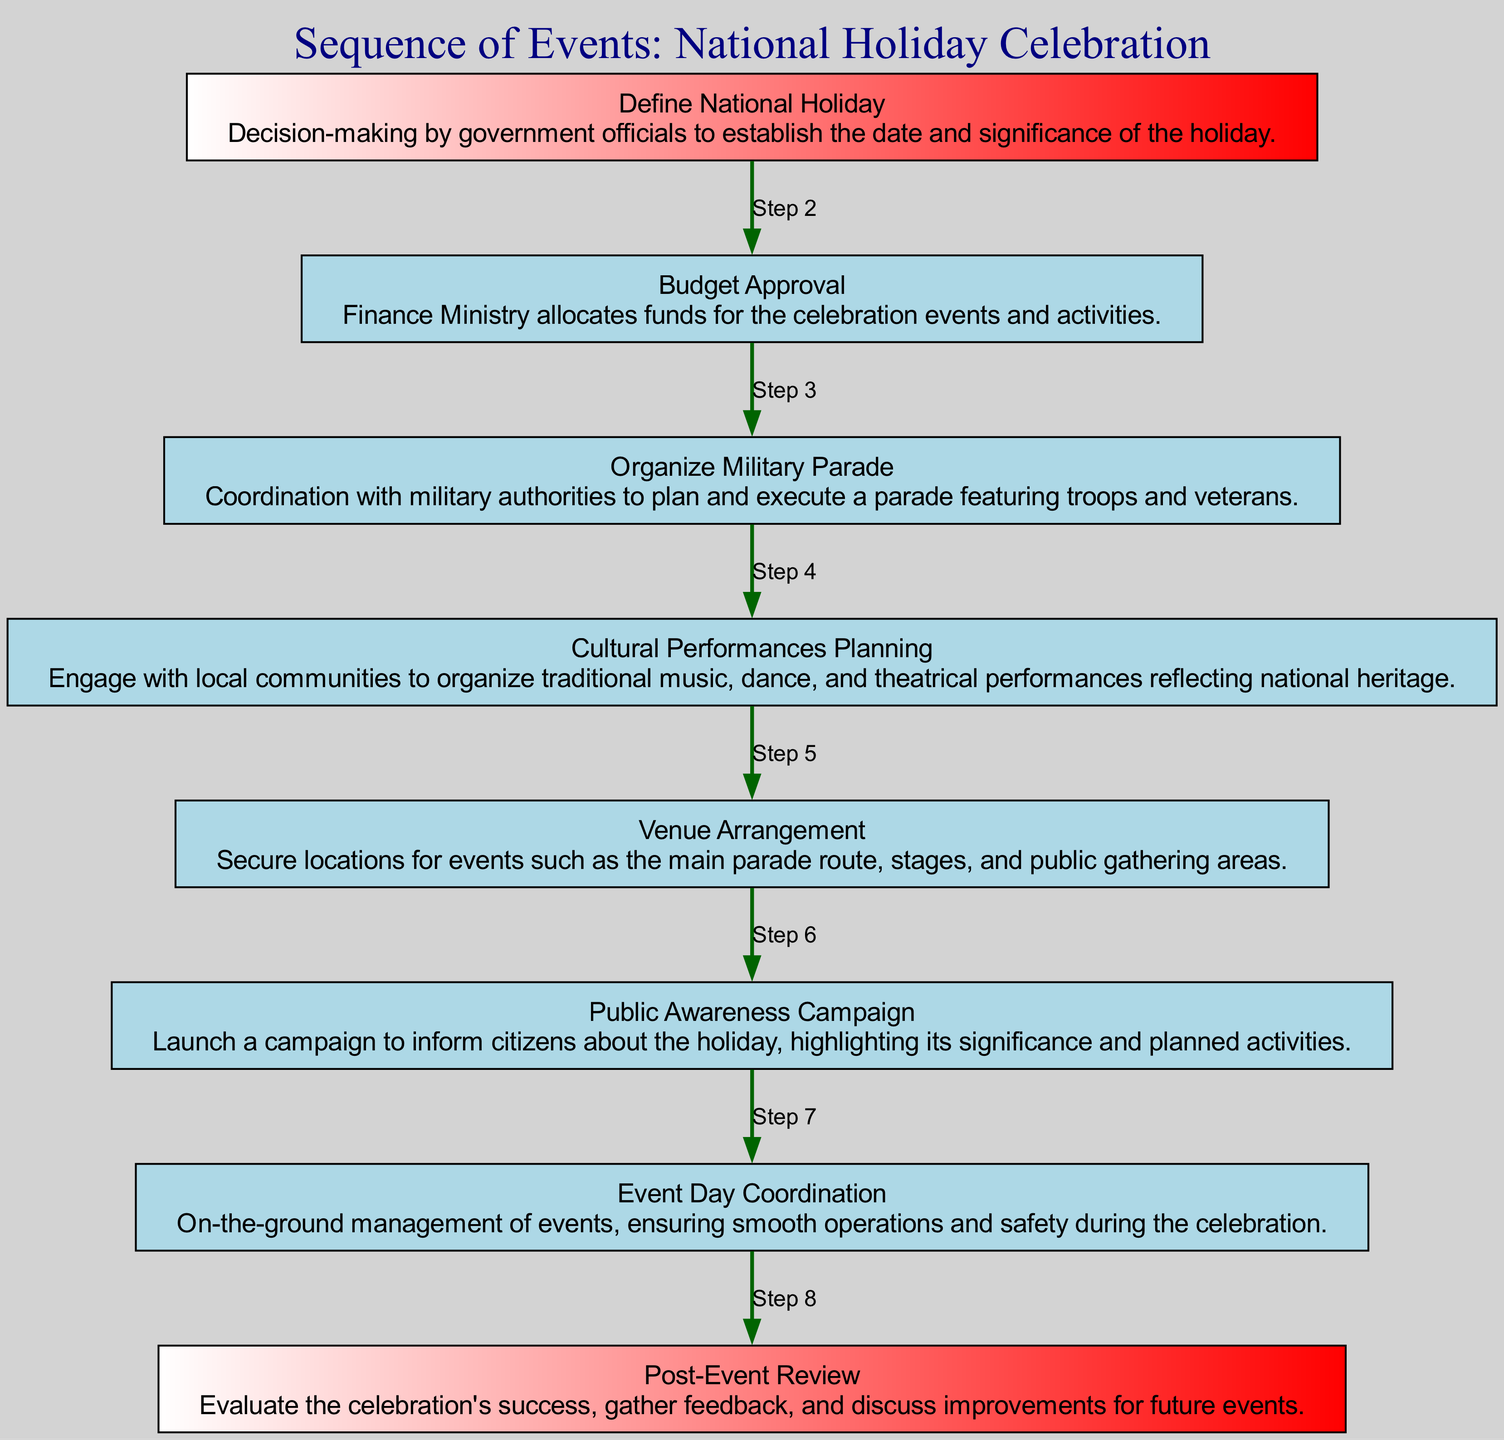What is the first event in the sequence? The first event is "Define National Holiday", as indicated by the first node in the diagram.
Answer: Define National Holiday How many events are in the diagram? There are 8 events listed in total; this can be counted directly from the nodes in the diagram.
Answer: 8 What is the last event in the sequence? The last event is "Post-Event Review", which is the last node shown in the diagram.
Answer: Post-Event Review What event directly follows "Budget Approval"? "Organize Military Parade" follows directly after "Budget Approval" because that node connects directly to it.
Answer: Organize Military Parade Which event is before "Public Awareness Campaign"? "Cultural Performances Planning" is the event that occurs before "Public Awareness Campaign", as seen in the flow of the diagram.
Answer: Cultural Performances Planning What color signifies the first and last nodes? The first and last nodes are both filled with the color combination of white, red, and green, reflecting the national colors.
Answer: White, red, green How many edges connect the events in the sequence? There are 7 edges connecting the events, as each event connects to the next one in the series, except for the first.
Answer: 7 What kind of campaign is launched before the event day? A "Public Awareness Campaign" is launched before the actual event day, according to the sequence.
Answer: Public Awareness Campaign What is the purpose of the "Post-Event Review"? The purpose of "Post-Event Review" is to evaluate the celebration's success, gather feedback, and discuss improvements for future events, described in its node.
Answer: Evaluate success and gather feedback 